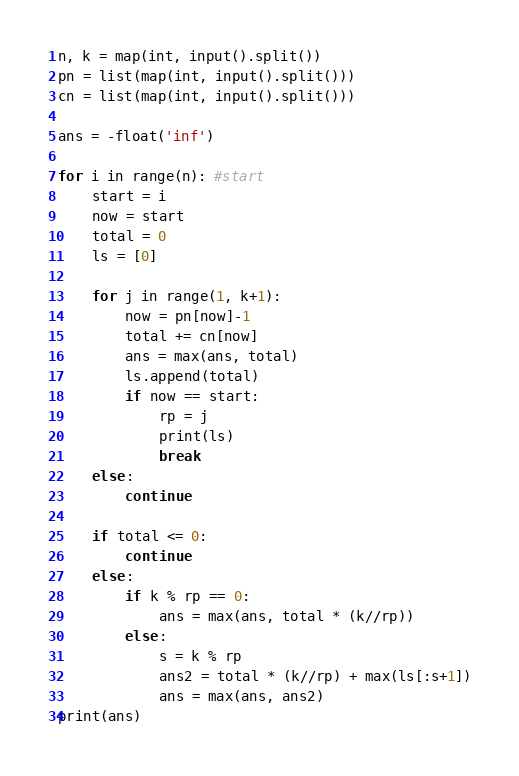Convert code to text. <code><loc_0><loc_0><loc_500><loc_500><_Python_>n, k = map(int, input().split())
pn = list(map(int, input().split()))
cn = list(map(int, input().split()))

ans = -float('inf')

for i in range(n): #start
    start = i
    now = start
    total = 0
    ls = [0]

    for j in range(1, k+1):
        now = pn[now]-1
        total += cn[now]
        ans = max(ans, total)
        ls.append(total)
        if now == start:
            rp = j
            print(ls)
            break
    else:
        continue

    if total <= 0:
        continue
    else:
        if k % rp == 0:
            ans = max(ans, total * (k//rp))
        else:
            s = k % rp
            ans2 = total * (k//rp) + max(ls[:s+1])
            ans = max(ans, ans2)
print(ans)</code> 